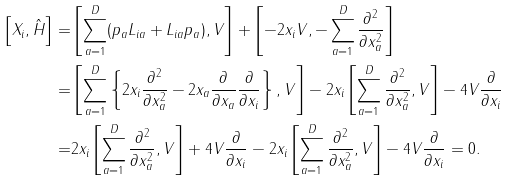<formula> <loc_0><loc_0><loc_500><loc_500>\left [ X _ { i } , \hat { H } \right ] = & \left [ \sum _ { a = 1 } ^ { D } ( p _ { a } L _ { i a } + L _ { i a } p _ { a } ) , V \right ] + \left [ - 2 x _ { i } V , - \sum _ { a = 1 } ^ { D } \frac { \partial ^ { 2 } } { \partial x _ { a } ^ { 2 } } \right ] \\ = & \left [ \sum _ { a = 1 } ^ { D } \left \{ 2 x _ { i } \frac { \partial ^ { 2 } } { \partial x _ { a } ^ { 2 } } - 2 x _ { a } \frac { \partial } { \partial x _ { a } } \frac { \partial } { \partial x _ { i } } \right \} , V \right ] - 2 x _ { i } \left [ \sum _ { a = 1 } ^ { D } \frac { \partial ^ { 2 } } { \partial x _ { a } ^ { 2 } } , V \right ] - 4 V \frac { \partial } { \partial x _ { i } } \\ = & 2 x _ { i } \left [ \sum _ { a = 1 } ^ { D } \frac { \partial ^ { 2 } } { \partial x _ { a } ^ { 2 } } , V \right ] + 4 V \frac { \partial } { \partial x _ { i } } - 2 x _ { i } \left [ \sum _ { a = 1 } ^ { D } \frac { \partial ^ { 2 } } { \partial x _ { a } ^ { 2 } } , V \right ] - 4 V \frac { \partial } { \partial x _ { i } } = 0 .</formula> 